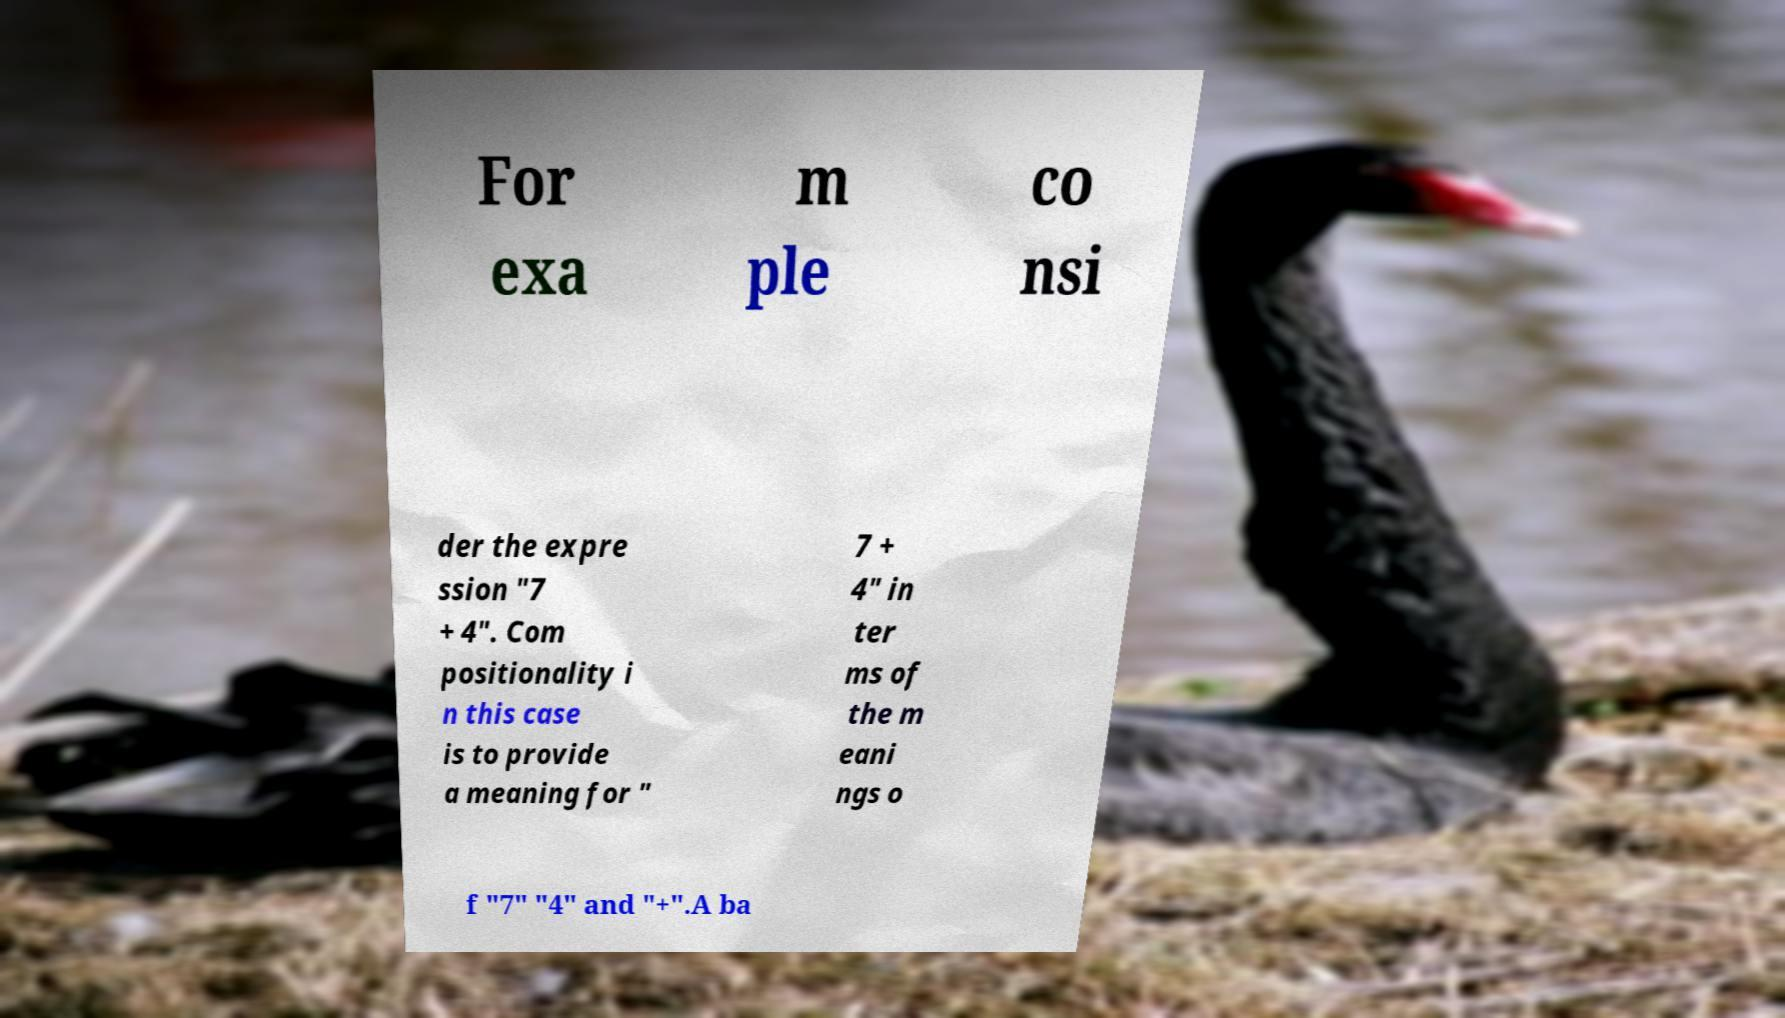Could you assist in decoding the text presented in this image and type it out clearly? For exa m ple co nsi der the expre ssion "7 + 4". Com positionality i n this case is to provide a meaning for " 7 + 4" in ter ms of the m eani ngs o f "7" "4" and "+".A ba 